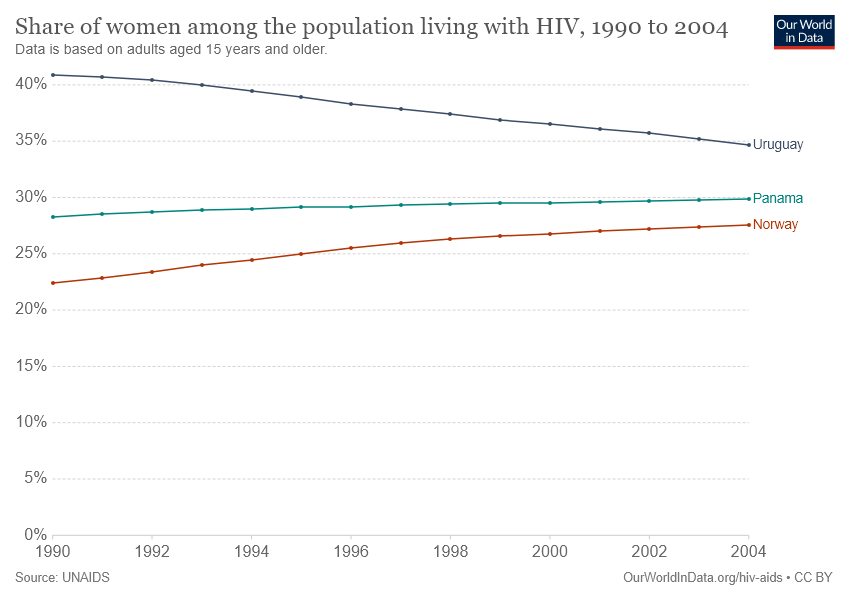Specify some key components in this picture. Based on the provided data, Uruguay has a slope that decreases compared to the other countries. The color of Norway's data is red. 